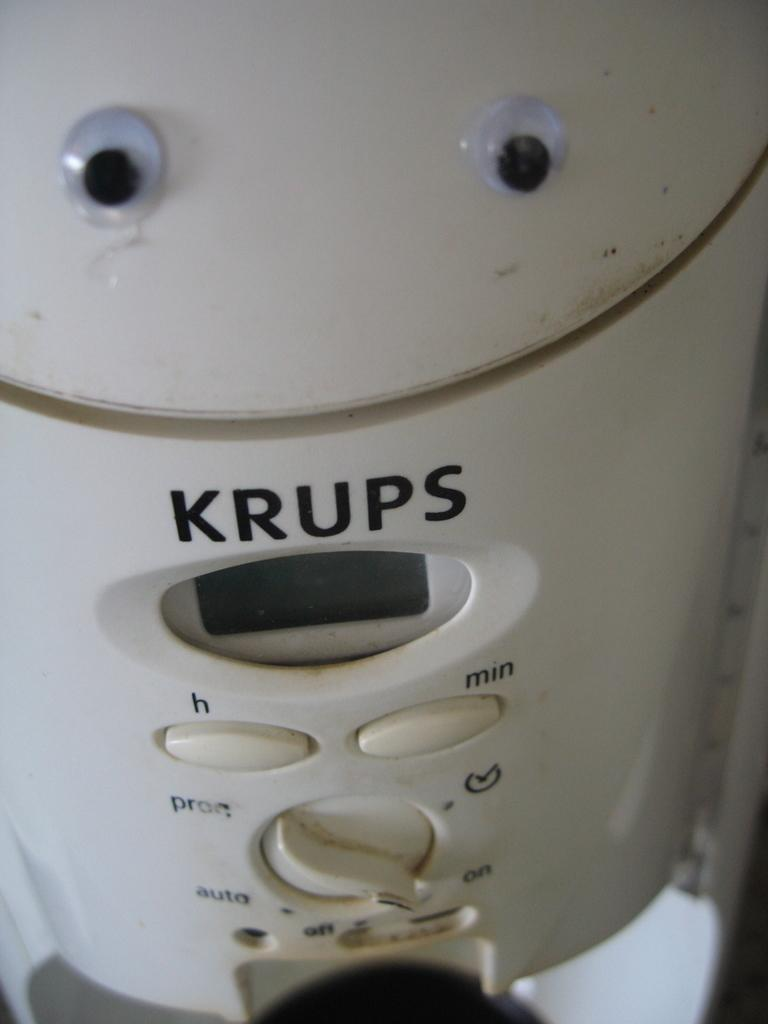<image>
Create a compact narrative representing the image presented. A KRUPS brand appliance has eyes stock on the top of it. 